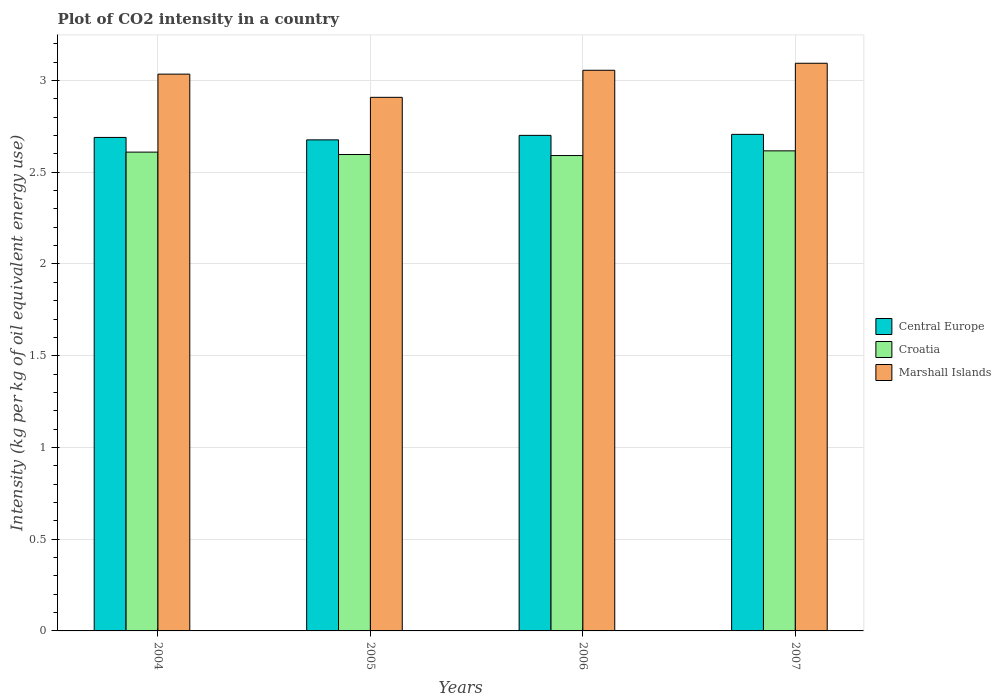How many groups of bars are there?
Give a very brief answer. 4. Are the number of bars per tick equal to the number of legend labels?
Provide a short and direct response. Yes. How many bars are there on the 3rd tick from the left?
Make the answer very short. 3. What is the label of the 3rd group of bars from the left?
Your answer should be very brief. 2006. In how many cases, is the number of bars for a given year not equal to the number of legend labels?
Keep it short and to the point. 0. What is the CO2 intensity in in Marshall Islands in 2006?
Keep it short and to the point. 3.06. Across all years, what is the maximum CO2 intensity in in Marshall Islands?
Keep it short and to the point. 3.09. Across all years, what is the minimum CO2 intensity in in Croatia?
Your answer should be very brief. 2.59. What is the total CO2 intensity in in Central Europe in the graph?
Your answer should be compact. 10.77. What is the difference between the CO2 intensity in in Marshall Islands in 2004 and that in 2007?
Your answer should be compact. -0.06. What is the difference between the CO2 intensity in in Marshall Islands in 2007 and the CO2 intensity in in Croatia in 2005?
Your answer should be compact. 0.5. What is the average CO2 intensity in in Croatia per year?
Provide a succinct answer. 2.6. In the year 2005, what is the difference between the CO2 intensity in in Central Europe and CO2 intensity in in Marshall Islands?
Your response must be concise. -0.23. In how many years, is the CO2 intensity in in Central Europe greater than 0.30000000000000004 kg?
Provide a short and direct response. 4. What is the ratio of the CO2 intensity in in Central Europe in 2006 to that in 2007?
Your response must be concise. 1. Is the CO2 intensity in in Croatia in 2005 less than that in 2007?
Give a very brief answer. Yes. Is the difference between the CO2 intensity in in Central Europe in 2006 and 2007 greater than the difference between the CO2 intensity in in Marshall Islands in 2006 and 2007?
Give a very brief answer. Yes. What is the difference between the highest and the second highest CO2 intensity in in Central Europe?
Provide a short and direct response. 0.01. What is the difference between the highest and the lowest CO2 intensity in in Marshall Islands?
Your answer should be very brief. 0.19. What does the 1st bar from the left in 2006 represents?
Give a very brief answer. Central Europe. What does the 2nd bar from the right in 2005 represents?
Your answer should be compact. Croatia. Is it the case that in every year, the sum of the CO2 intensity in in Croatia and CO2 intensity in in Central Europe is greater than the CO2 intensity in in Marshall Islands?
Provide a short and direct response. Yes. Are all the bars in the graph horizontal?
Provide a short and direct response. No. Are the values on the major ticks of Y-axis written in scientific E-notation?
Keep it short and to the point. No. Does the graph contain any zero values?
Give a very brief answer. No. How are the legend labels stacked?
Offer a very short reply. Vertical. What is the title of the graph?
Provide a short and direct response. Plot of CO2 intensity in a country. What is the label or title of the X-axis?
Keep it short and to the point. Years. What is the label or title of the Y-axis?
Offer a terse response. Intensity (kg per kg of oil equivalent energy use). What is the Intensity (kg per kg of oil equivalent energy use) in Central Europe in 2004?
Ensure brevity in your answer.  2.69. What is the Intensity (kg per kg of oil equivalent energy use) of Croatia in 2004?
Offer a terse response. 2.61. What is the Intensity (kg per kg of oil equivalent energy use) in Marshall Islands in 2004?
Provide a short and direct response. 3.03. What is the Intensity (kg per kg of oil equivalent energy use) of Central Europe in 2005?
Your answer should be very brief. 2.68. What is the Intensity (kg per kg of oil equivalent energy use) of Croatia in 2005?
Provide a succinct answer. 2.6. What is the Intensity (kg per kg of oil equivalent energy use) of Marshall Islands in 2005?
Your answer should be very brief. 2.91. What is the Intensity (kg per kg of oil equivalent energy use) of Central Europe in 2006?
Provide a succinct answer. 2.7. What is the Intensity (kg per kg of oil equivalent energy use) in Croatia in 2006?
Offer a very short reply. 2.59. What is the Intensity (kg per kg of oil equivalent energy use) in Marshall Islands in 2006?
Offer a terse response. 3.06. What is the Intensity (kg per kg of oil equivalent energy use) of Central Europe in 2007?
Your response must be concise. 2.71. What is the Intensity (kg per kg of oil equivalent energy use) in Croatia in 2007?
Ensure brevity in your answer.  2.62. What is the Intensity (kg per kg of oil equivalent energy use) in Marshall Islands in 2007?
Provide a short and direct response. 3.09. Across all years, what is the maximum Intensity (kg per kg of oil equivalent energy use) in Central Europe?
Your answer should be compact. 2.71. Across all years, what is the maximum Intensity (kg per kg of oil equivalent energy use) of Croatia?
Offer a very short reply. 2.62. Across all years, what is the maximum Intensity (kg per kg of oil equivalent energy use) in Marshall Islands?
Provide a succinct answer. 3.09. Across all years, what is the minimum Intensity (kg per kg of oil equivalent energy use) of Central Europe?
Give a very brief answer. 2.68. Across all years, what is the minimum Intensity (kg per kg of oil equivalent energy use) of Croatia?
Your answer should be very brief. 2.59. Across all years, what is the minimum Intensity (kg per kg of oil equivalent energy use) of Marshall Islands?
Provide a succinct answer. 2.91. What is the total Intensity (kg per kg of oil equivalent energy use) of Central Europe in the graph?
Your answer should be compact. 10.77. What is the total Intensity (kg per kg of oil equivalent energy use) of Croatia in the graph?
Offer a terse response. 10.41. What is the total Intensity (kg per kg of oil equivalent energy use) of Marshall Islands in the graph?
Your response must be concise. 12.09. What is the difference between the Intensity (kg per kg of oil equivalent energy use) of Central Europe in 2004 and that in 2005?
Your answer should be compact. 0.01. What is the difference between the Intensity (kg per kg of oil equivalent energy use) in Croatia in 2004 and that in 2005?
Make the answer very short. 0.01. What is the difference between the Intensity (kg per kg of oil equivalent energy use) of Marshall Islands in 2004 and that in 2005?
Offer a terse response. 0.13. What is the difference between the Intensity (kg per kg of oil equivalent energy use) of Central Europe in 2004 and that in 2006?
Your response must be concise. -0.01. What is the difference between the Intensity (kg per kg of oil equivalent energy use) in Croatia in 2004 and that in 2006?
Your answer should be very brief. 0.02. What is the difference between the Intensity (kg per kg of oil equivalent energy use) of Marshall Islands in 2004 and that in 2006?
Provide a short and direct response. -0.02. What is the difference between the Intensity (kg per kg of oil equivalent energy use) of Central Europe in 2004 and that in 2007?
Make the answer very short. -0.02. What is the difference between the Intensity (kg per kg of oil equivalent energy use) of Croatia in 2004 and that in 2007?
Make the answer very short. -0.01. What is the difference between the Intensity (kg per kg of oil equivalent energy use) in Marshall Islands in 2004 and that in 2007?
Your answer should be compact. -0.06. What is the difference between the Intensity (kg per kg of oil equivalent energy use) of Central Europe in 2005 and that in 2006?
Provide a succinct answer. -0.02. What is the difference between the Intensity (kg per kg of oil equivalent energy use) in Croatia in 2005 and that in 2006?
Make the answer very short. 0.01. What is the difference between the Intensity (kg per kg of oil equivalent energy use) of Marshall Islands in 2005 and that in 2006?
Make the answer very short. -0.15. What is the difference between the Intensity (kg per kg of oil equivalent energy use) in Central Europe in 2005 and that in 2007?
Keep it short and to the point. -0.03. What is the difference between the Intensity (kg per kg of oil equivalent energy use) in Croatia in 2005 and that in 2007?
Your answer should be compact. -0.02. What is the difference between the Intensity (kg per kg of oil equivalent energy use) in Marshall Islands in 2005 and that in 2007?
Provide a succinct answer. -0.19. What is the difference between the Intensity (kg per kg of oil equivalent energy use) of Central Europe in 2006 and that in 2007?
Offer a very short reply. -0.01. What is the difference between the Intensity (kg per kg of oil equivalent energy use) in Croatia in 2006 and that in 2007?
Provide a short and direct response. -0.03. What is the difference between the Intensity (kg per kg of oil equivalent energy use) in Marshall Islands in 2006 and that in 2007?
Provide a succinct answer. -0.04. What is the difference between the Intensity (kg per kg of oil equivalent energy use) of Central Europe in 2004 and the Intensity (kg per kg of oil equivalent energy use) of Croatia in 2005?
Keep it short and to the point. 0.09. What is the difference between the Intensity (kg per kg of oil equivalent energy use) of Central Europe in 2004 and the Intensity (kg per kg of oil equivalent energy use) of Marshall Islands in 2005?
Provide a short and direct response. -0.22. What is the difference between the Intensity (kg per kg of oil equivalent energy use) in Croatia in 2004 and the Intensity (kg per kg of oil equivalent energy use) in Marshall Islands in 2005?
Your answer should be very brief. -0.3. What is the difference between the Intensity (kg per kg of oil equivalent energy use) in Central Europe in 2004 and the Intensity (kg per kg of oil equivalent energy use) in Croatia in 2006?
Keep it short and to the point. 0.1. What is the difference between the Intensity (kg per kg of oil equivalent energy use) in Central Europe in 2004 and the Intensity (kg per kg of oil equivalent energy use) in Marshall Islands in 2006?
Your response must be concise. -0.37. What is the difference between the Intensity (kg per kg of oil equivalent energy use) of Croatia in 2004 and the Intensity (kg per kg of oil equivalent energy use) of Marshall Islands in 2006?
Offer a very short reply. -0.45. What is the difference between the Intensity (kg per kg of oil equivalent energy use) in Central Europe in 2004 and the Intensity (kg per kg of oil equivalent energy use) in Croatia in 2007?
Your answer should be compact. 0.07. What is the difference between the Intensity (kg per kg of oil equivalent energy use) in Central Europe in 2004 and the Intensity (kg per kg of oil equivalent energy use) in Marshall Islands in 2007?
Your response must be concise. -0.4. What is the difference between the Intensity (kg per kg of oil equivalent energy use) of Croatia in 2004 and the Intensity (kg per kg of oil equivalent energy use) of Marshall Islands in 2007?
Your answer should be compact. -0.48. What is the difference between the Intensity (kg per kg of oil equivalent energy use) of Central Europe in 2005 and the Intensity (kg per kg of oil equivalent energy use) of Croatia in 2006?
Provide a succinct answer. 0.09. What is the difference between the Intensity (kg per kg of oil equivalent energy use) of Central Europe in 2005 and the Intensity (kg per kg of oil equivalent energy use) of Marshall Islands in 2006?
Your answer should be very brief. -0.38. What is the difference between the Intensity (kg per kg of oil equivalent energy use) of Croatia in 2005 and the Intensity (kg per kg of oil equivalent energy use) of Marshall Islands in 2006?
Make the answer very short. -0.46. What is the difference between the Intensity (kg per kg of oil equivalent energy use) in Central Europe in 2005 and the Intensity (kg per kg of oil equivalent energy use) in Croatia in 2007?
Provide a short and direct response. 0.06. What is the difference between the Intensity (kg per kg of oil equivalent energy use) in Central Europe in 2005 and the Intensity (kg per kg of oil equivalent energy use) in Marshall Islands in 2007?
Offer a very short reply. -0.42. What is the difference between the Intensity (kg per kg of oil equivalent energy use) in Croatia in 2005 and the Intensity (kg per kg of oil equivalent energy use) in Marshall Islands in 2007?
Give a very brief answer. -0.5. What is the difference between the Intensity (kg per kg of oil equivalent energy use) of Central Europe in 2006 and the Intensity (kg per kg of oil equivalent energy use) of Croatia in 2007?
Your answer should be very brief. 0.08. What is the difference between the Intensity (kg per kg of oil equivalent energy use) in Central Europe in 2006 and the Intensity (kg per kg of oil equivalent energy use) in Marshall Islands in 2007?
Your response must be concise. -0.39. What is the difference between the Intensity (kg per kg of oil equivalent energy use) of Croatia in 2006 and the Intensity (kg per kg of oil equivalent energy use) of Marshall Islands in 2007?
Provide a short and direct response. -0.5. What is the average Intensity (kg per kg of oil equivalent energy use) of Central Europe per year?
Keep it short and to the point. 2.69. What is the average Intensity (kg per kg of oil equivalent energy use) in Croatia per year?
Offer a terse response. 2.6. What is the average Intensity (kg per kg of oil equivalent energy use) of Marshall Islands per year?
Offer a very short reply. 3.02. In the year 2004, what is the difference between the Intensity (kg per kg of oil equivalent energy use) in Central Europe and Intensity (kg per kg of oil equivalent energy use) in Marshall Islands?
Provide a short and direct response. -0.34. In the year 2004, what is the difference between the Intensity (kg per kg of oil equivalent energy use) of Croatia and Intensity (kg per kg of oil equivalent energy use) of Marshall Islands?
Give a very brief answer. -0.42. In the year 2005, what is the difference between the Intensity (kg per kg of oil equivalent energy use) in Central Europe and Intensity (kg per kg of oil equivalent energy use) in Croatia?
Keep it short and to the point. 0.08. In the year 2005, what is the difference between the Intensity (kg per kg of oil equivalent energy use) in Central Europe and Intensity (kg per kg of oil equivalent energy use) in Marshall Islands?
Keep it short and to the point. -0.23. In the year 2005, what is the difference between the Intensity (kg per kg of oil equivalent energy use) in Croatia and Intensity (kg per kg of oil equivalent energy use) in Marshall Islands?
Ensure brevity in your answer.  -0.31. In the year 2006, what is the difference between the Intensity (kg per kg of oil equivalent energy use) of Central Europe and Intensity (kg per kg of oil equivalent energy use) of Croatia?
Give a very brief answer. 0.11. In the year 2006, what is the difference between the Intensity (kg per kg of oil equivalent energy use) of Central Europe and Intensity (kg per kg of oil equivalent energy use) of Marshall Islands?
Offer a terse response. -0.35. In the year 2006, what is the difference between the Intensity (kg per kg of oil equivalent energy use) of Croatia and Intensity (kg per kg of oil equivalent energy use) of Marshall Islands?
Your response must be concise. -0.46. In the year 2007, what is the difference between the Intensity (kg per kg of oil equivalent energy use) in Central Europe and Intensity (kg per kg of oil equivalent energy use) in Croatia?
Provide a succinct answer. 0.09. In the year 2007, what is the difference between the Intensity (kg per kg of oil equivalent energy use) of Central Europe and Intensity (kg per kg of oil equivalent energy use) of Marshall Islands?
Offer a very short reply. -0.39. In the year 2007, what is the difference between the Intensity (kg per kg of oil equivalent energy use) of Croatia and Intensity (kg per kg of oil equivalent energy use) of Marshall Islands?
Your response must be concise. -0.48. What is the ratio of the Intensity (kg per kg of oil equivalent energy use) of Marshall Islands in 2004 to that in 2005?
Your answer should be compact. 1.04. What is the ratio of the Intensity (kg per kg of oil equivalent energy use) in Central Europe in 2004 to that in 2006?
Offer a terse response. 1. What is the ratio of the Intensity (kg per kg of oil equivalent energy use) in Croatia in 2004 to that in 2007?
Your response must be concise. 1. What is the ratio of the Intensity (kg per kg of oil equivalent energy use) of Marshall Islands in 2004 to that in 2007?
Give a very brief answer. 0.98. What is the ratio of the Intensity (kg per kg of oil equivalent energy use) in Central Europe in 2005 to that in 2006?
Provide a succinct answer. 0.99. What is the ratio of the Intensity (kg per kg of oil equivalent energy use) of Marshall Islands in 2005 to that in 2006?
Your response must be concise. 0.95. What is the ratio of the Intensity (kg per kg of oil equivalent energy use) of Central Europe in 2005 to that in 2007?
Your answer should be very brief. 0.99. What is the ratio of the Intensity (kg per kg of oil equivalent energy use) in Croatia in 2005 to that in 2007?
Ensure brevity in your answer.  0.99. What is the ratio of the Intensity (kg per kg of oil equivalent energy use) of Croatia in 2006 to that in 2007?
Provide a short and direct response. 0.99. What is the ratio of the Intensity (kg per kg of oil equivalent energy use) in Marshall Islands in 2006 to that in 2007?
Provide a succinct answer. 0.99. What is the difference between the highest and the second highest Intensity (kg per kg of oil equivalent energy use) of Central Europe?
Your answer should be very brief. 0.01. What is the difference between the highest and the second highest Intensity (kg per kg of oil equivalent energy use) in Croatia?
Your response must be concise. 0.01. What is the difference between the highest and the second highest Intensity (kg per kg of oil equivalent energy use) of Marshall Islands?
Your answer should be compact. 0.04. What is the difference between the highest and the lowest Intensity (kg per kg of oil equivalent energy use) in Central Europe?
Your answer should be very brief. 0.03. What is the difference between the highest and the lowest Intensity (kg per kg of oil equivalent energy use) in Croatia?
Your answer should be very brief. 0.03. What is the difference between the highest and the lowest Intensity (kg per kg of oil equivalent energy use) of Marshall Islands?
Make the answer very short. 0.19. 